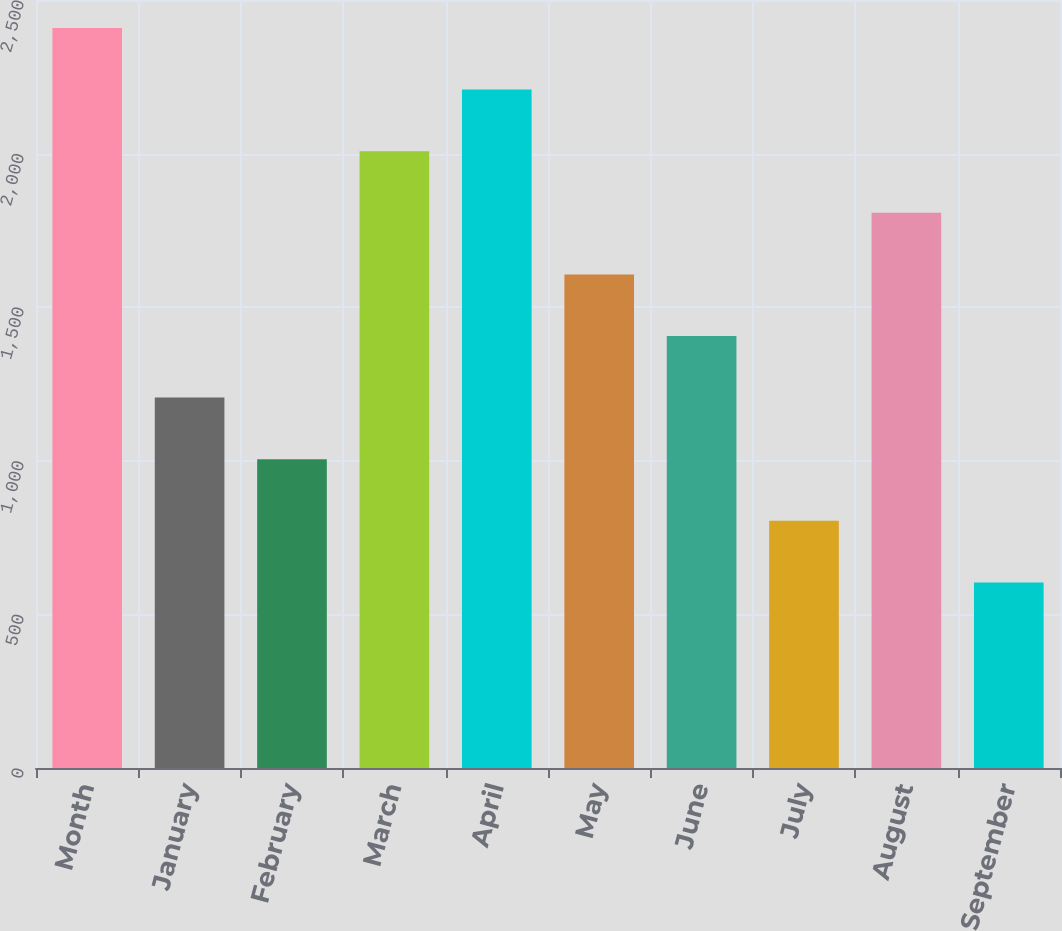<chart> <loc_0><loc_0><loc_500><loc_500><bar_chart><fcel>Month<fcel>January<fcel>February<fcel>March<fcel>April<fcel>May<fcel>June<fcel>July<fcel>August<fcel>September<nl><fcel>2409.13<fcel>1205.65<fcel>1005.07<fcel>2007.97<fcel>2208.55<fcel>1606.81<fcel>1406.23<fcel>804.49<fcel>1807.39<fcel>603.91<nl></chart> 